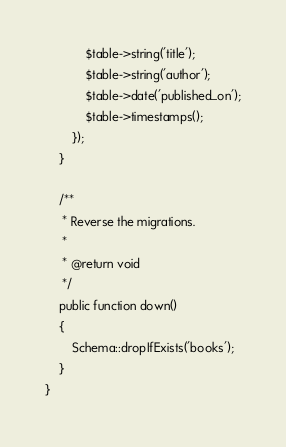Convert code to text. <code><loc_0><loc_0><loc_500><loc_500><_PHP_>            $table->string('title');
            $table->string('author');
            $table->date('published_on');
            $table->timestamps();
        });
    }

    /**
     * Reverse the migrations.
     *
     * @return void
     */
    public function down()
    {
        Schema::dropIfExists('books');
    }
}
</code> 